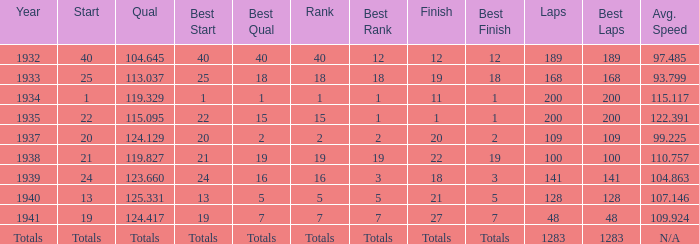What was the finish place with a qual of 123.660? 18.0. 